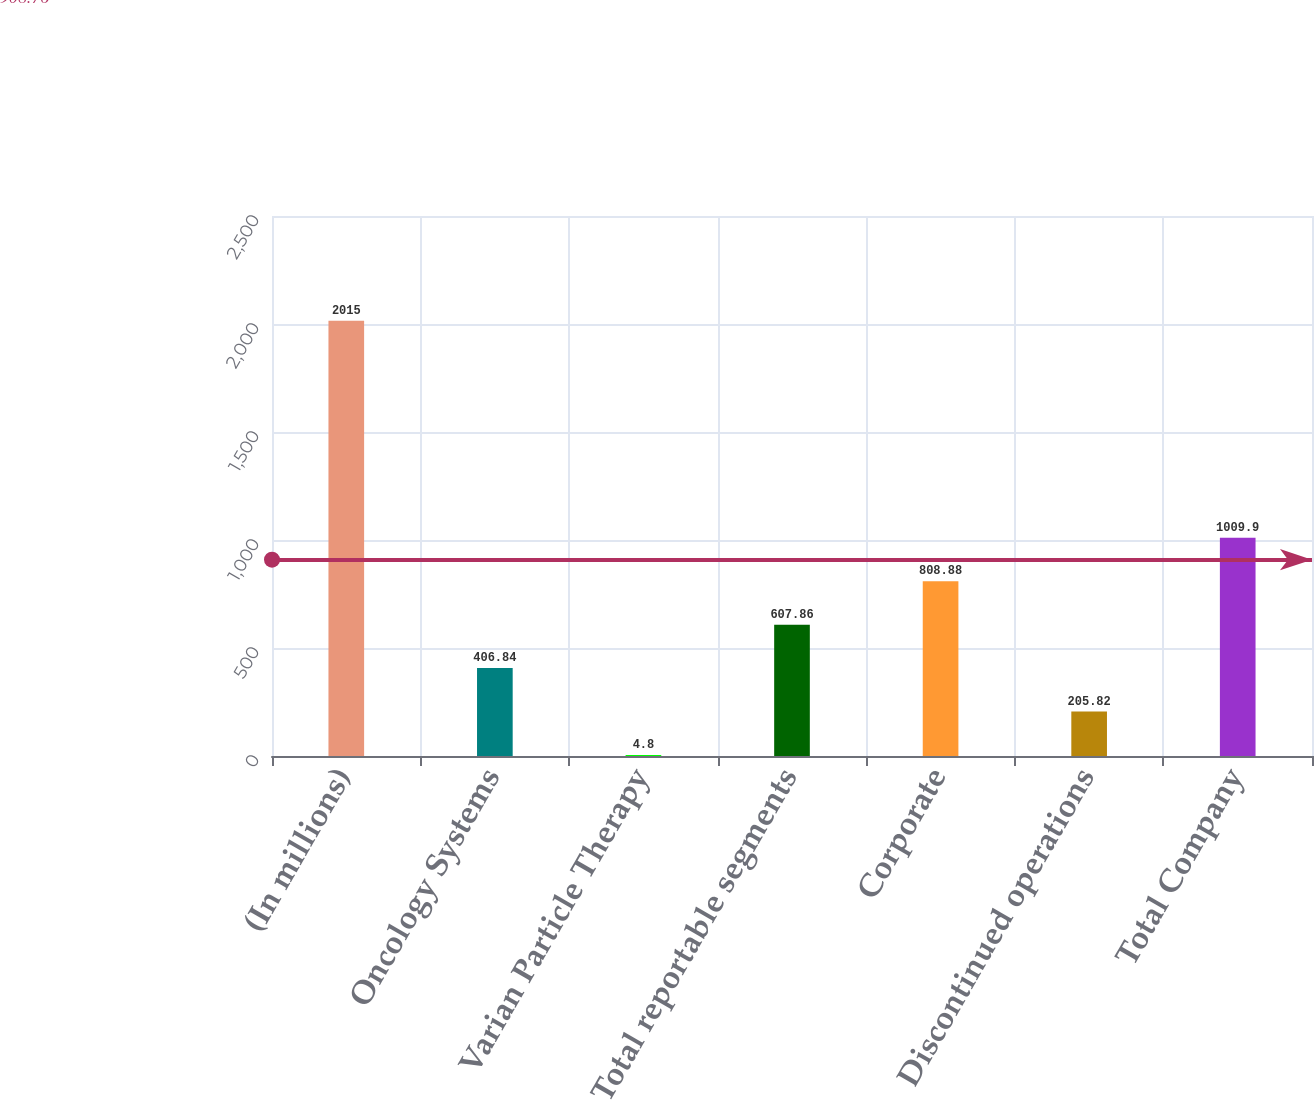Convert chart. <chart><loc_0><loc_0><loc_500><loc_500><bar_chart><fcel>(In millions)<fcel>Oncology Systems<fcel>Varian Particle Therapy<fcel>Total reportable segments<fcel>Corporate<fcel>Discontinued operations<fcel>Total Company<nl><fcel>2015<fcel>406.84<fcel>4.8<fcel>607.86<fcel>808.88<fcel>205.82<fcel>1009.9<nl></chart> 